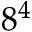Convert formula to latex. <formula><loc_0><loc_0><loc_500><loc_500>8 ^ { 4 }</formula> 